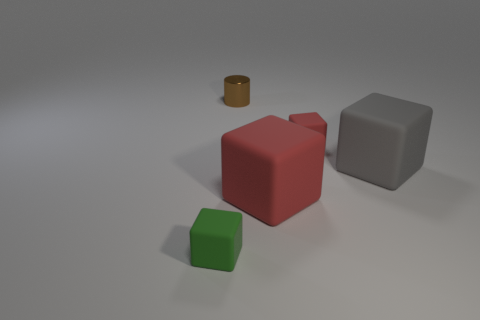There is a green block; is it the same size as the gray matte block in front of the small brown metal cylinder?
Give a very brief answer. No. What size is the brown shiny cylinder?
Provide a short and direct response. Small. There is another large cube that is made of the same material as the big red cube; what is its color?
Offer a terse response. Gray. What number of big cubes have the same material as the tiny green thing?
Offer a terse response. 2. How many things are small rubber cubes or large rubber blocks that are on the left side of the gray matte cube?
Offer a very short reply. 3. Do the small cube that is behind the gray cube and the small brown object have the same material?
Your response must be concise. No. What is the color of the rubber cube that is the same size as the gray matte object?
Offer a terse response. Red. Is there another big thing of the same shape as the gray matte object?
Your answer should be compact. Yes. There is a small matte cube behind the green thing that is left of the red object that is in front of the big gray object; what is its color?
Give a very brief answer. Red. How many shiny objects are red cubes or brown cylinders?
Give a very brief answer. 1. 